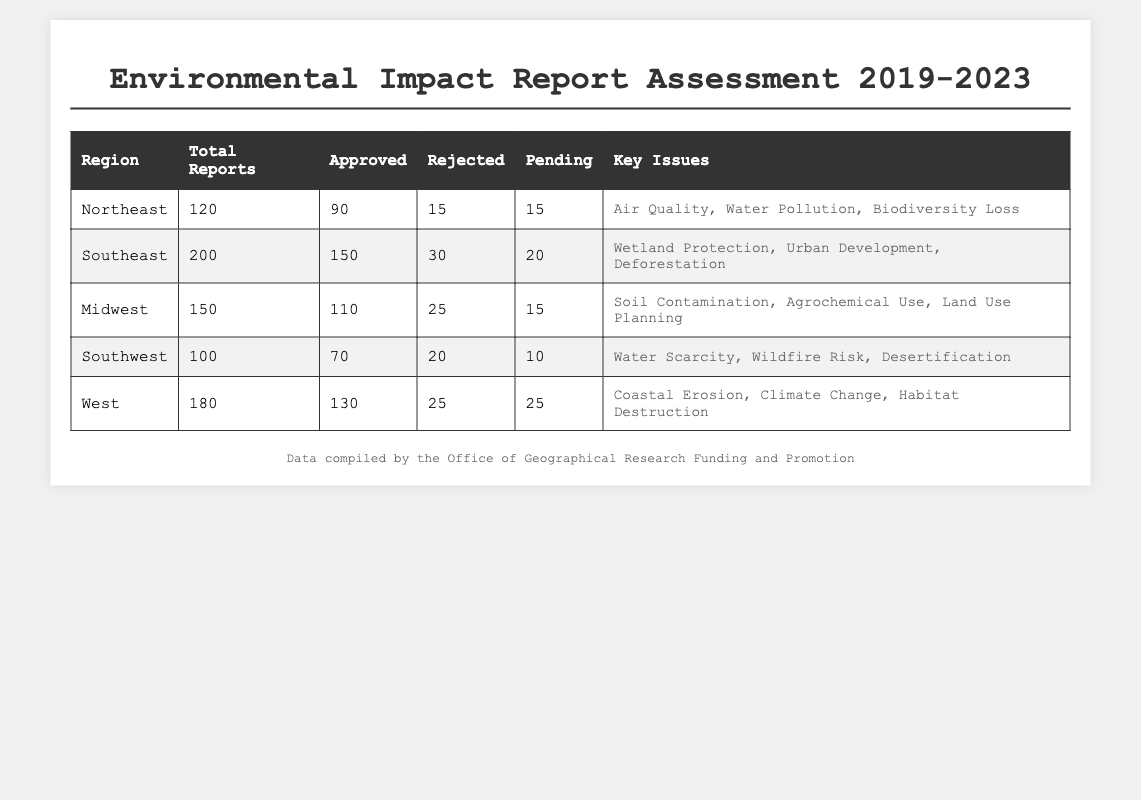What is the total number of reports submitted from the Southeast region? The table shows the Total Reports column for the Southeast region, which is 200.
Answer: 200 How many reports were rejected in the Midwest region? The table indicates that 25 reports were rejected in the Midwest region.
Answer: 25 Which region has the highest number of approved reports? Looking at the Approved column, the Southeast region has the highest count at 150.
Answer: Southeast What is the percentage of approved reports in the Northeast region? The Northeast region has 90 approved out of 120 total reports. To find the percentage, calculate (90/120) * 100, which equals 75%.
Answer: 75% Which region has the least number of total reports? The Southwest region has the least total reports, with a count of 100.
Answer: Southwest How many reports are currently pending in the West region? The Pending column for the West region shows there are 25 reports pending.
Answer: 25 Which region has the most varied key issues? Comparing the key issues, the Southeast region has the most varied key issues: Wetland Protection, Urban Development, and Deforestation, each from different environmental themes.
Answer: Southeast What is the total number of rejected reports across all regions? To calculate the total rejected reports, add the rejected counts: 15 (Northeast) + 30 (Southeast) + 25 (Midwest) + 20 (Southwest) + 25 (West) = 115.
Answer: 115 Are there any regions with pending reports fewer than 15? The Southwest region has 10 pending reports, which is fewer than 15.
Answer: Yes What is the average number of approved reports across all five regions? The approved reports are: 90 (Northeast) + 150 (Southeast) + 110 (Midwest) + 70 (Southwest) + 130 (West) = 550. There are 5 regions, so the average is 550/5 = 110.
Answer: 110 Is the air quality a key issue in any region? Yes, air quality is listed as a key issue in the Northeast region.
Answer: Yes 